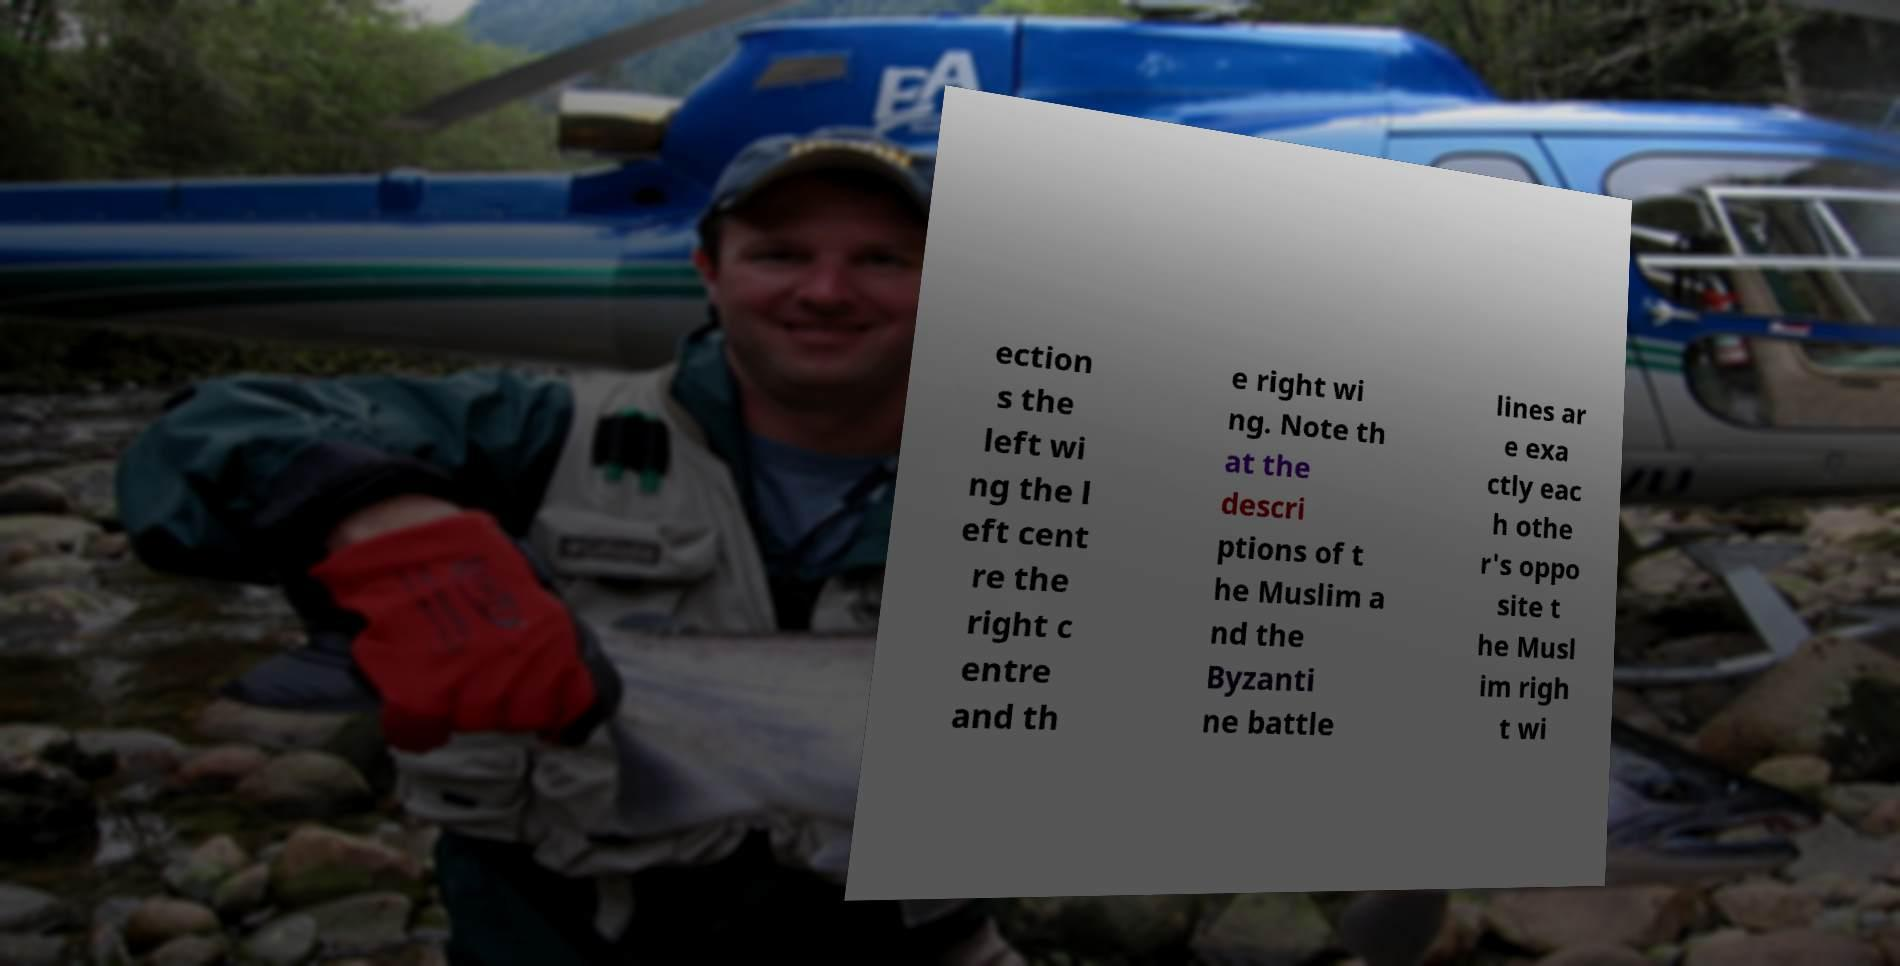Please read and relay the text visible in this image. What does it say? ection s the left wi ng the l eft cent re the right c entre and th e right wi ng. Note th at the descri ptions of t he Muslim a nd the Byzanti ne battle lines ar e exa ctly eac h othe r's oppo site t he Musl im righ t wi 